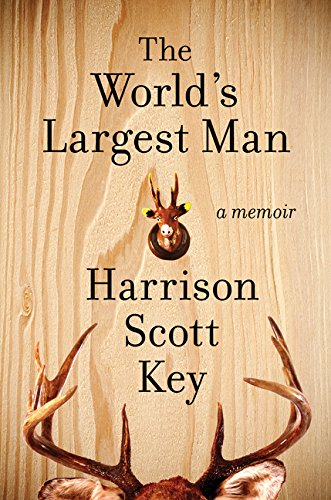Who is the author of this book? The author of the book pictured is Harrison Scott Key, known for his humorous writing style. 